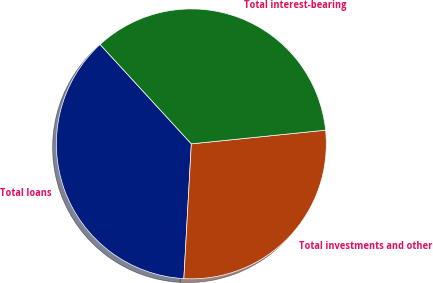Convert chart. <chart><loc_0><loc_0><loc_500><loc_500><pie_chart><fcel>Total loans<fcel>Total investments and other<fcel>Total interest-bearing<nl><fcel>37.3%<fcel>27.5%<fcel>35.2%<nl></chart> 